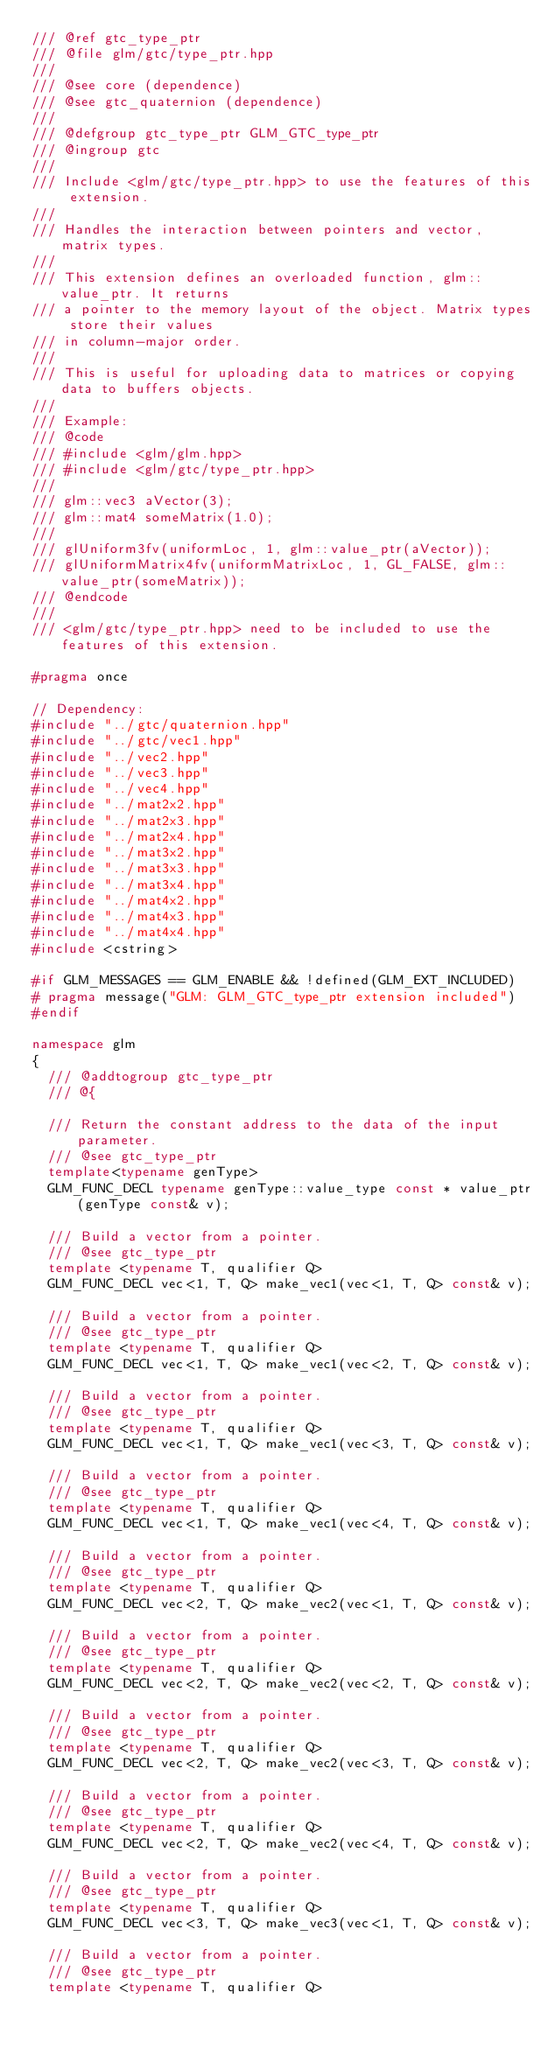<code> <loc_0><loc_0><loc_500><loc_500><_C++_>/// @ref gtc_type_ptr
/// @file glm/gtc/type_ptr.hpp
///
/// @see core (dependence)
/// @see gtc_quaternion (dependence)
///
/// @defgroup gtc_type_ptr GLM_GTC_type_ptr
/// @ingroup gtc
///
/// Include <glm/gtc/type_ptr.hpp> to use the features of this extension.
///
/// Handles the interaction between pointers and vector, matrix types.
///
/// This extension defines an overloaded function, glm::value_ptr. It returns
/// a pointer to the memory layout of the object. Matrix types store their values
/// in column-major order.
///
/// This is useful for uploading data to matrices or copying data to buffers objects.
///
/// Example:
/// @code
/// #include <glm/glm.hpp>
/// #include <glm/gtc/type_ptr.hpp>
///
/// glm::vec3 aVector(3);
/// glm::mat4 someMatrix(1.0);
///
/// glUniform3fv(uniformLoc, 1, glm::value_ptr(aVector));
/// glUniformMatrix4fv(uniformMatrixLoc, 1, GL_FALSE, glm::value_ptr(someMatrix));
/// @endcode
///
/// <glm/gtc/type_ptr.hpp> need to be included to use the features of this extension.

#pragma once

// Dependency:
#include "../gtc/quaternion.hpp"
#include "../gtc/vec1.hpp"
#include "../vec2.hpp"
#include "../vec3.hpp"
#include "../vec4.hpp"
#include "../mat2x2.hpp"
#include "../mat2x3.hpp"
#include "../mat2x4.hpp"
#include "../mat3x2.hpp"
#include "../mat3x3.hpp"
#include "../mat3x4.hpp"
#include "../mat4x2.hpp"
#include "../mat4x3.hpp"
#include "../mat4x4.hpp"
#include <cstring>

#if GLM_MESSAGES == GLM_ENABLE && !defined(GLM_EXT_INCLUDED)
#	pragma message("GLM: GLM_GTC_type_ptr extension included")
#endif

namespace glm
{
	/// @addtogroup gtc_type_ptr
	/// @{

	/// Return the constant address to the data of the input parameter.
	/// @see gtc_type_ptr
	template<typename genType>
	GLM_FUNC_DECL typename genType::value_type const * value_ptr(genType const& v);

	/// Build a vector from a pointer.
	/// @see gtc_type_ptr
	template <typename T, qualifier Q>
	GLM_FUNC_DECL vec<1, T, Q> make_vec1(vec<1, T, Q> const& v);

	/// Build a vector from a pointer.
	/// @see gtc_type_ptr
	template <typename T, qualifier Q>
	GLM_FUNC_DECL vec<1, T, Q> make_vec1(vec<2, T, Q> const& v);

	/// Build a vector from a pointer.
	/// @see gtc_type_ptr
	template <typename T, qualifier Q>
	GLM_FUNC_DECL vec<1, T, Q> make_vec1(vec<3, T, Q> const& v);

	/// Build a vector from a pointer.
	/// @see gtc_type_ptr
	template <typename T, qualifier Q>
	GLM_FUNC_DECL vec<1, T, Q> make_vec1(vec<4, T, Q> const& v);

	/// Build a vector from a pointer.
	/// @see gtc_type_ptr
	template <typename T, qualifier Q>
	GLM_FUNC_DECL vec<2, T, Q> make_vec2(vec<1, T, Q> const& v);

	/// Build a vector from a pointer.
	/// @see gtc_type_ptr
	template <typename T, qualifier Q>
	GLM_FUNC_DECL vec<2, T, Q> make_vec2(vec<2, T, Q> const& v);

	/// Build a vector from a pointer.
	/// @see gtc_type_ptr
	template <typename T, qualifier Q>
	GLM_FUNC_DECL vec<2, T, Q> make_vec2(vec<3, T, Q> const& v);

	/// Build a vector from a pointer.
	/// @see gtc_type_ptr
	template <typename T, qualifier Q>
	GLM_FUNC_DECL vec<2, T, Q> make_vec2(vec<4, T, Q> const& v);

	/// Build a vector from a pointer.
	/// @see gtc_type_ptr
	template <typename T, qualifier Q>
	GLM_FUNC_DECL vec<3, T, Q> make_vec3(vec<1, T, Q> const& v);

	/// Build a vector from a pointer.
	/// @see gtc_type_ptr
	template <typename T, qualifier Q></code> 